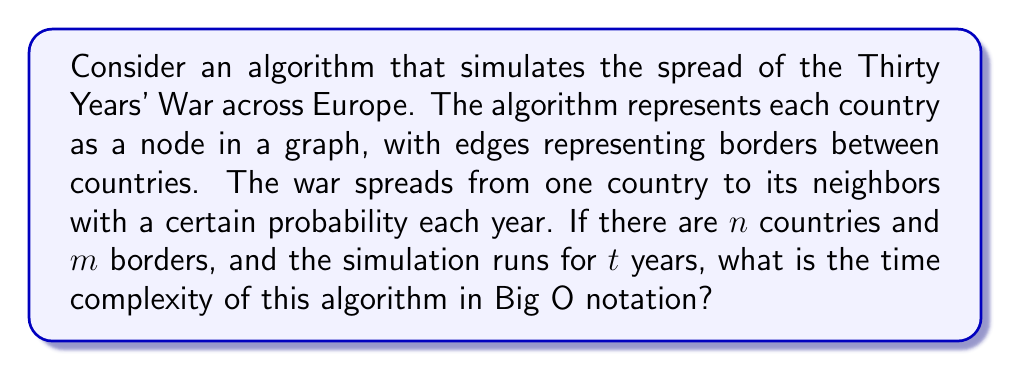Provide a solution to this math problem. To analyze the time complexity of this algorithm, let's break it down step-by-step:

1. Initialization:
   - Creating the graph with $n$ nodes and $m$ edges: $O(n + m)$

2. Simulation for each year:
   - For each of the $t$ years, we need to:
     a. Check each country (node) if it's involved in the war: $O(n)$
     b. For each involved country, check its neighbors (adjacent edges): $O(m)$ in total
     c. For each neighbor, calculate the probability of war spreading: $O(1)$

3. Total operations per year:
   $O(n + m)$

4. Overall time complexity:
   - Initialization: $O(n + m)$
   - Simulation for $t$ years: $O(t(n + m))$

5. Combining the steps:
   $O(n + m + t(n + m))$

6. Simplifying:
   $O((t+1)(n + m))$

7. Since $t$ is typically much larger than 1 in historical simulations, we can further simplify:
   $O(t(n + m))$

This time complexity reflects that the algorithm needs to process each country and each border for each year of the simulation.
Answer: $O(t(n + m))$, where $t$ is the number of years, $n$ is the number of countries, and $m$ is the number of borders. 